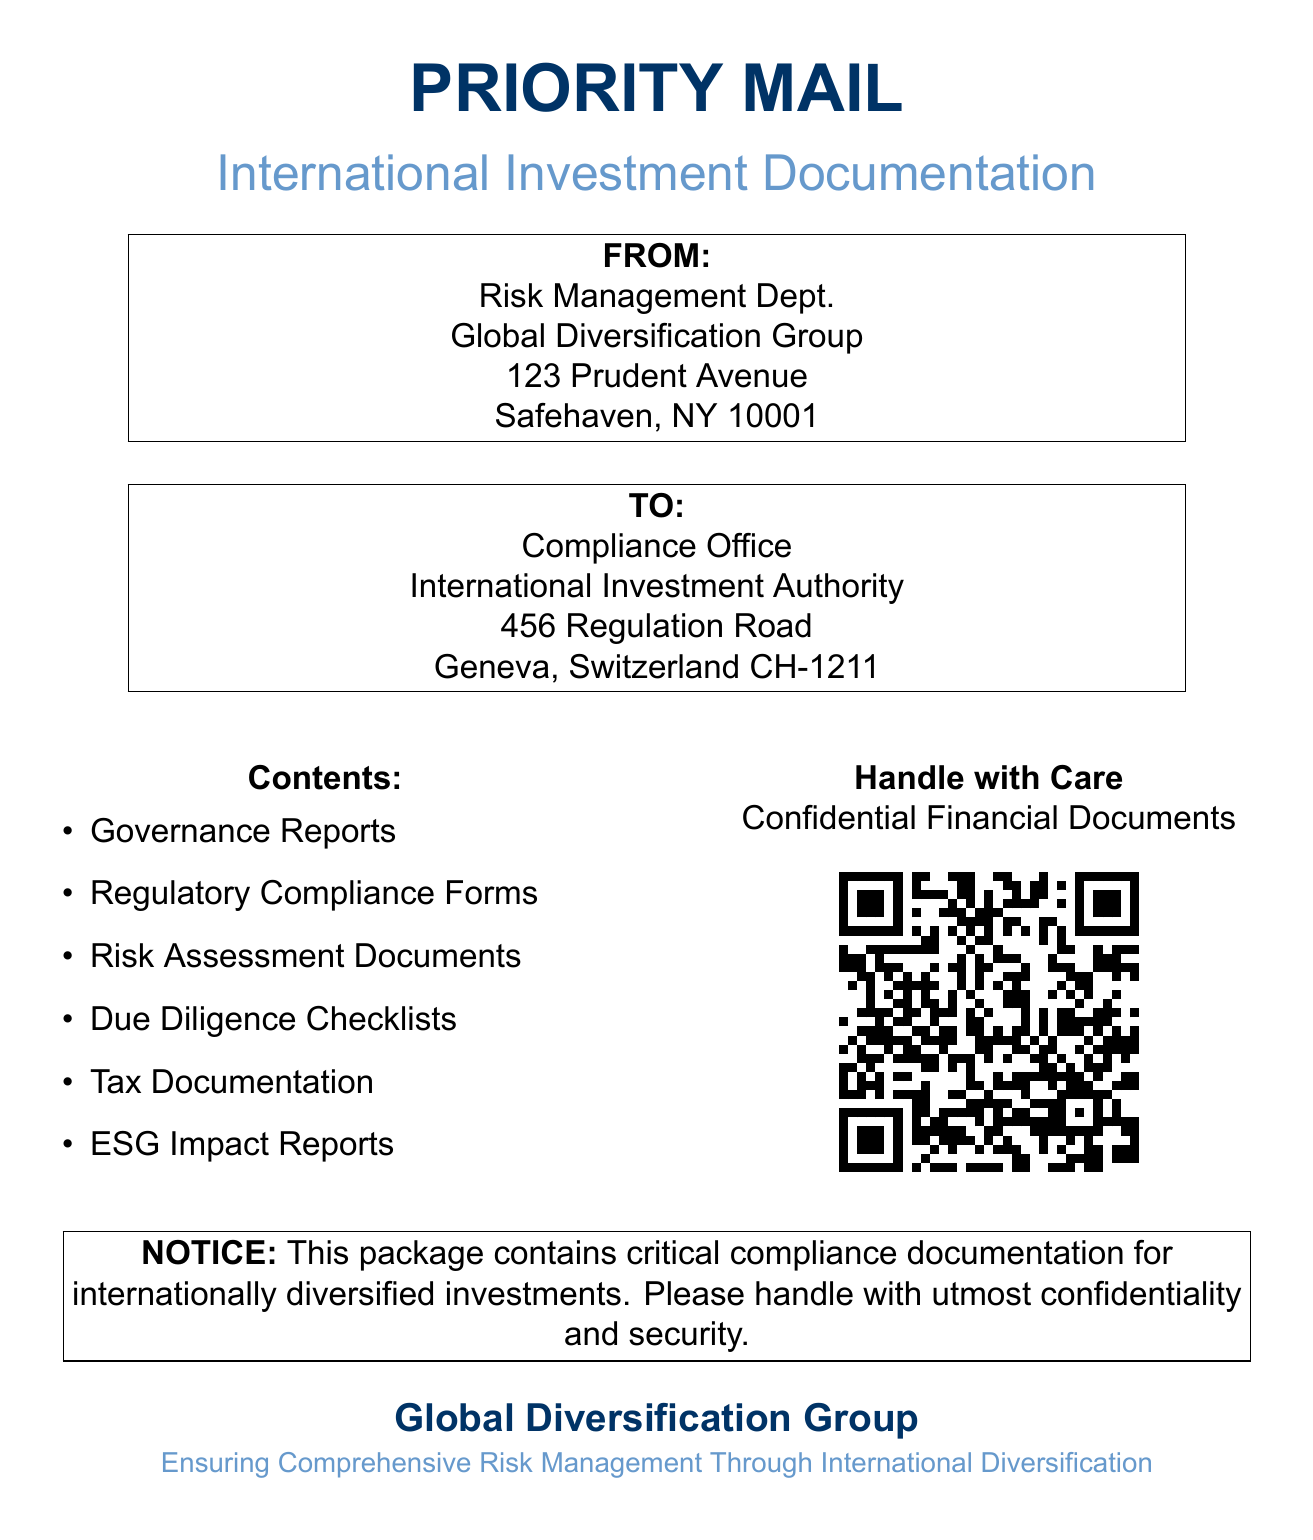What is the name of the sender department? The sender department is mentioned in the "FROM" section of the document as the Risk Management Dept.
Answer: Risk Management Dept What is the address of the recipient? The recipient's address is stated under the "TO" section of the document, detailing their location in Geneva, Switzerland.
Answer: 456 Regulation Road, Geneva, Switzerland CH-1211 What type of documents are included in the shipment? The "Contents" section lists the types of documents, revealing essential compliance documentation that is sent.
Answer: Governance Reports, Regulatory Compliance Forms, Risk Assessment Documents, Due Diligence Checklists, Tax Documentation, ESG Impact Reports What does the notice in the document emphasize? The notice highlights the critical nature of the contents and requests careful handling, as indicated in the document text.
Answer: Confidentiality and security Which group is responsible for this shipment? The sender's organization is stated in the document header, indicating their identity and focus.
Answer: Global Diversification Group What color is used for the main document header? The document specifies the color used for the header text, reflecting on its visual style.
Answer: RGB(0,51,102) What is the main theme of the Global Diversification Group? The theme is referenced in the footer of the document, reflecting their philosophy on investment management.
Answer: Comprehensive Risk Management Through International Diversification What QR code destination is mentioned in the document? The QR code provides a link that redirects to information about compliance, specified under its code in the document.
Answer: https://www.diversificationgroup.com/compliance 